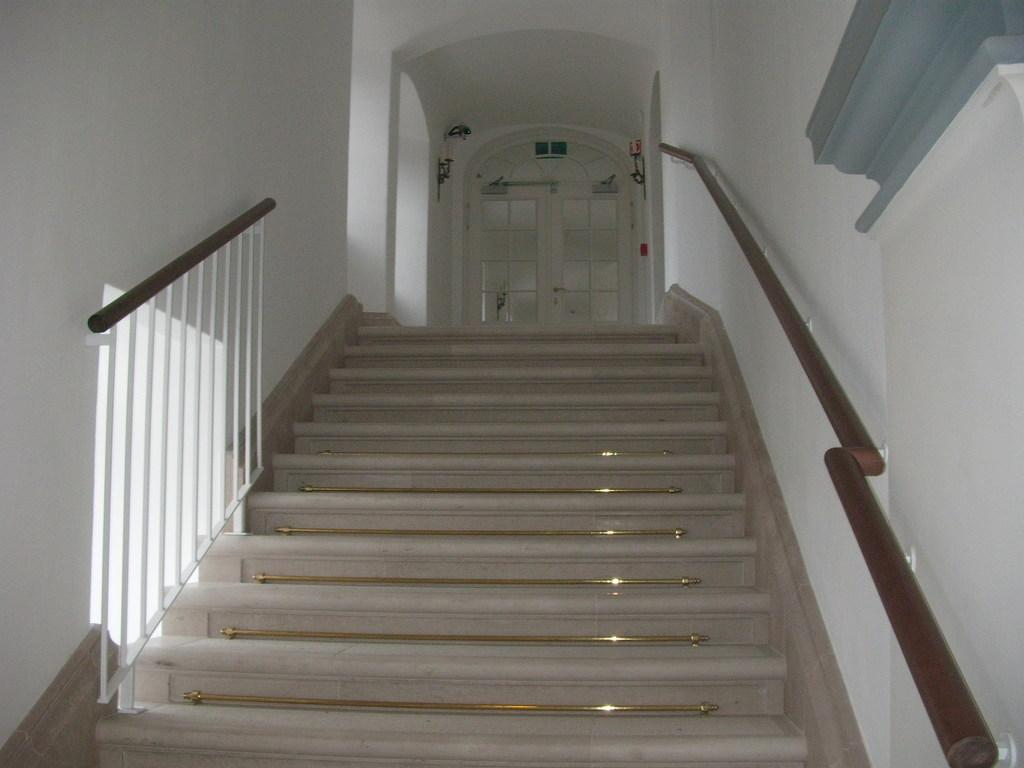What type of architectural feature is present in the image? There are stairs in the image. To which building do the stairs belong? The stairs belong to a building. What is blocking the entrance to the stairs? There is a closed glass door in front of the stairs. What can be seen attached to the wall in the image? There are objects attached to the wall in the image. Can you see a bridge connecting the two sides of the stairs in the image? No, there is no bridge connecting the two sides of the stairs in the image. 